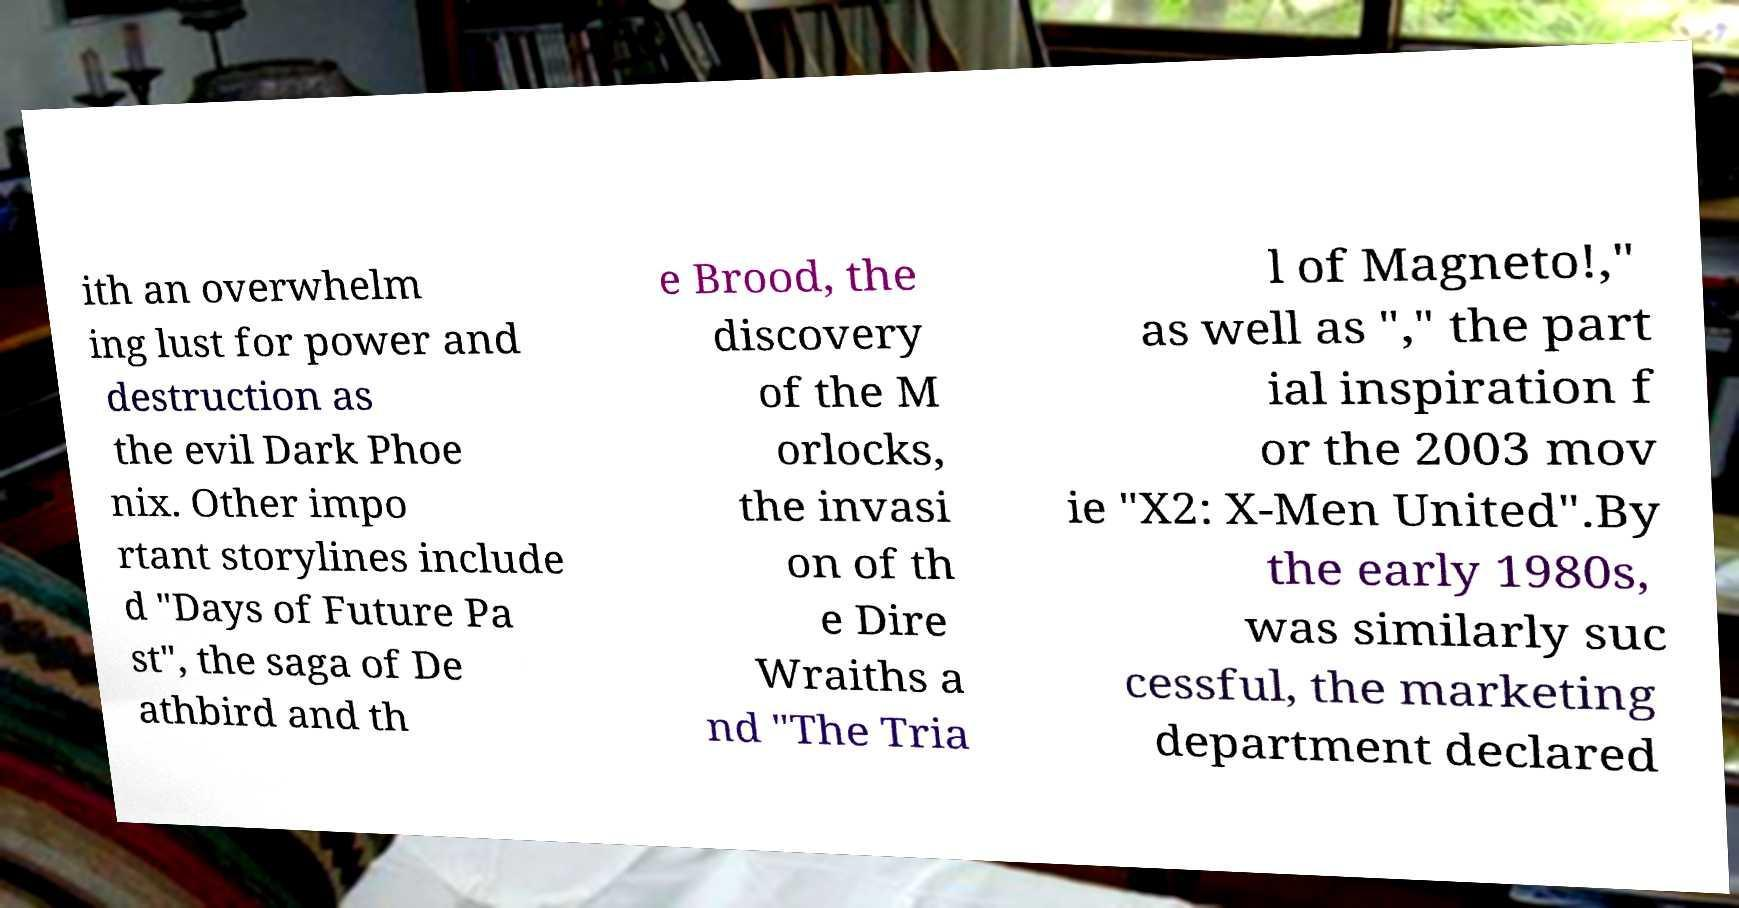There's text embedded in this image that I need extracted. Can you transcribe it verbatim? ith an overwhelm ing lust for power and destruction as the evil Dark Phoe nix. Other impo rtant storylines include d "Days of Future Pa st", the saga of De athbird and th e Brood, the discovery of the M orlocks, the invasi on of th e Dire Wraiths a nd "The Tria l of Magneto!," as well as "," the part ial inspiration f or the 2003 mov ie "X2: X-Men United".By the early 1980s, was similarly suc cessful, the marketing department declared 